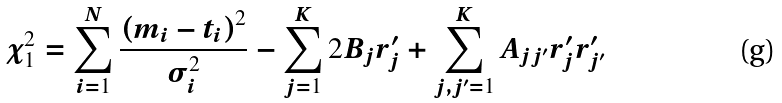Convert formula to latex. <formula><loc_0><loc_0><loc_500><loc_500>\chi _ { 1 } ^ { 2 } = \sum _ { i = 1 } ^ { N } \frac { \left ( m _ { i } - t _ { i } \right ) ^ { 2 } } { \sigma _ { i } ^ { 2 } } - \sum _ { j = 1 } ^ { K } 2 B _ { j } r _ { j } ^ { \prime } + \sum _ { j , j ^ { \prime } = 1 } ^ { K } A _ { j j ^ { \prime } } r _ { j } ^ { \prime } r _ { j ^ { \prime } } ^ { \prime }</formula> 